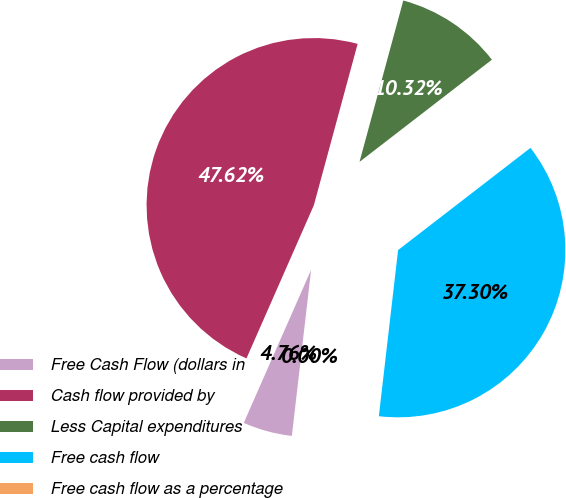<chart> <loc_0><loc_0><loc_500><loc_500><pie_chart><fcel>Free Cash Flow (dollars in<fcel>Cash flow provided by<fcel>Less Capital expenditures<fcel>Free cash flow<fcel>Free cash flow as a percentage<nl><fcel>4.76%<fcel>47.62%<fcel>10.32%<fcel>37.3%<fcel>0.0%<nl></chart> 